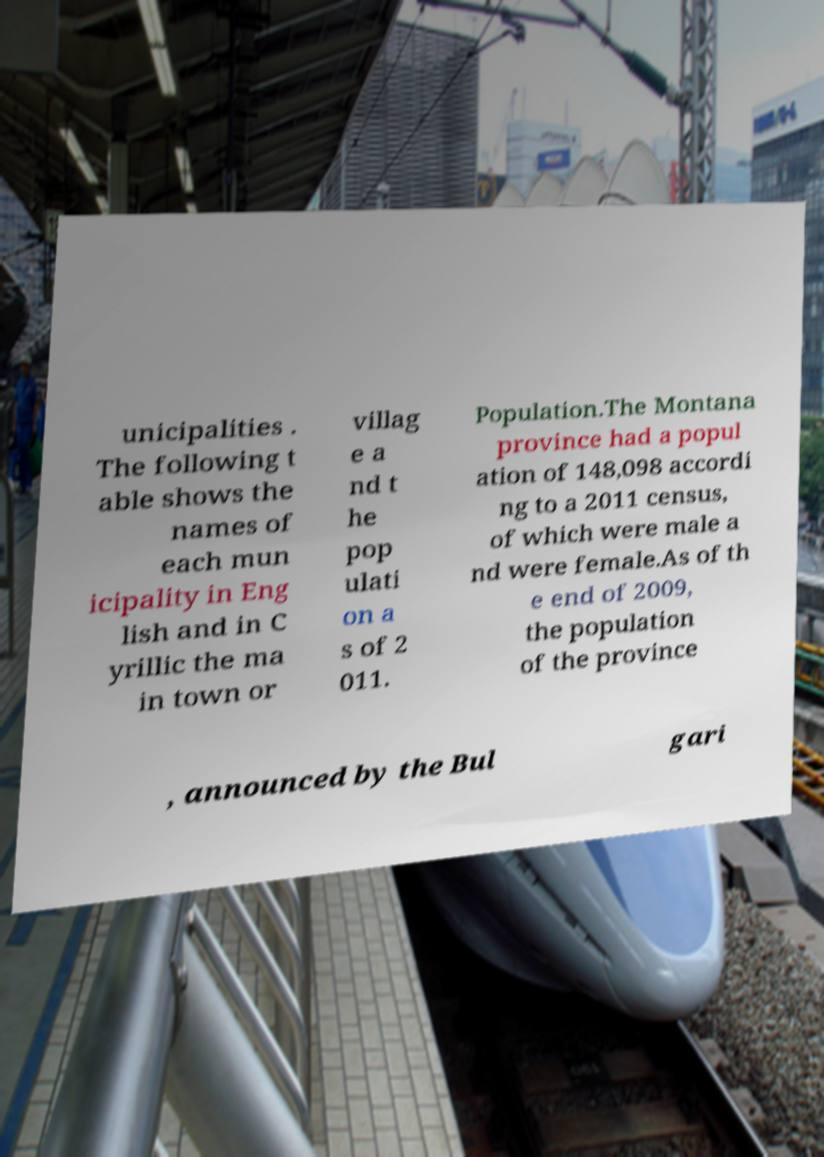There's text embedded in this image that I need extracted. Can you transcribe it verbatim? unicipalities . The following t able shows the names of each mun icipality in Eng lish and in C yrillic the ma in town or villag e a nd t he pop ulati on a s of 2 011. Population.The Montana province had a popul ation of 148,098 accordi ng to a 2011 census, of which were male a nd were female.As of th e end of 2009, the population of the province , announced by the Bul gari 